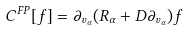<formula> <loc_0><loc_0><loc_500><loc_500>C ^ { F P } [ f ] = \partial _ { v _ { \alpha } } ( R _ { \alpha } + D \partial _ { v _ { \alpha } } ) f</formula> 